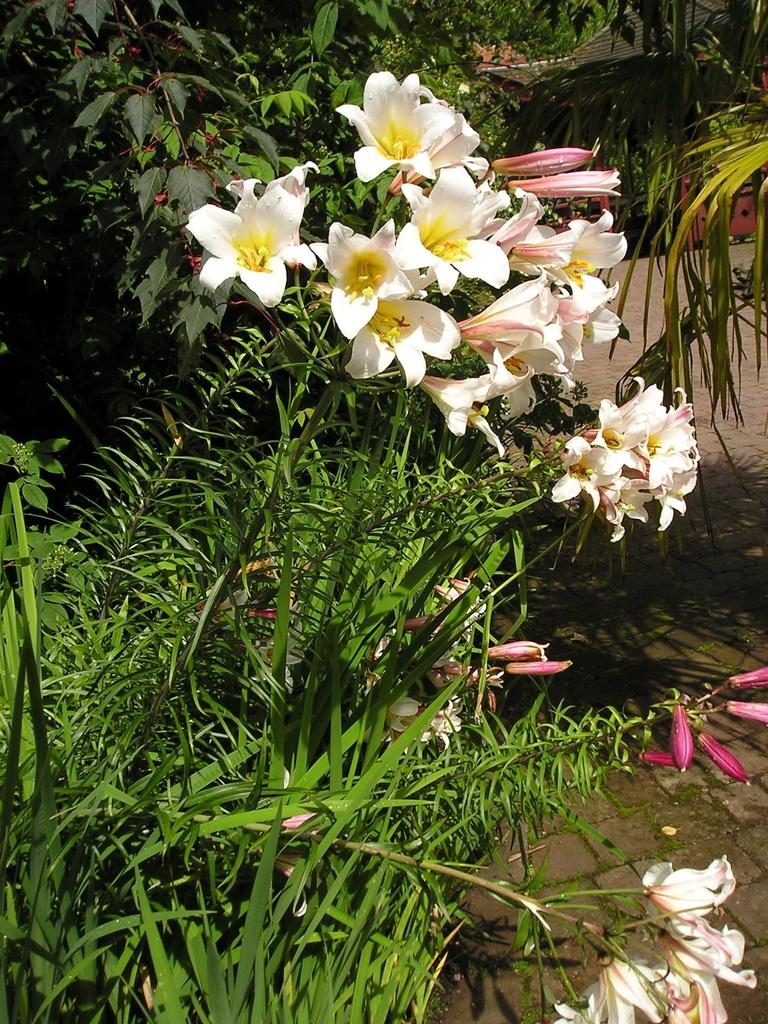What type of plants can be seen in the image? There are flower plants in the image. How are the flower plants described? The flower plants are described as beautiful. What is located beside the flower plants? There is a path beside the flower plants. What type of slope can be seen in the image? There is no slope present in the image. The image only features flower plants and a path. 